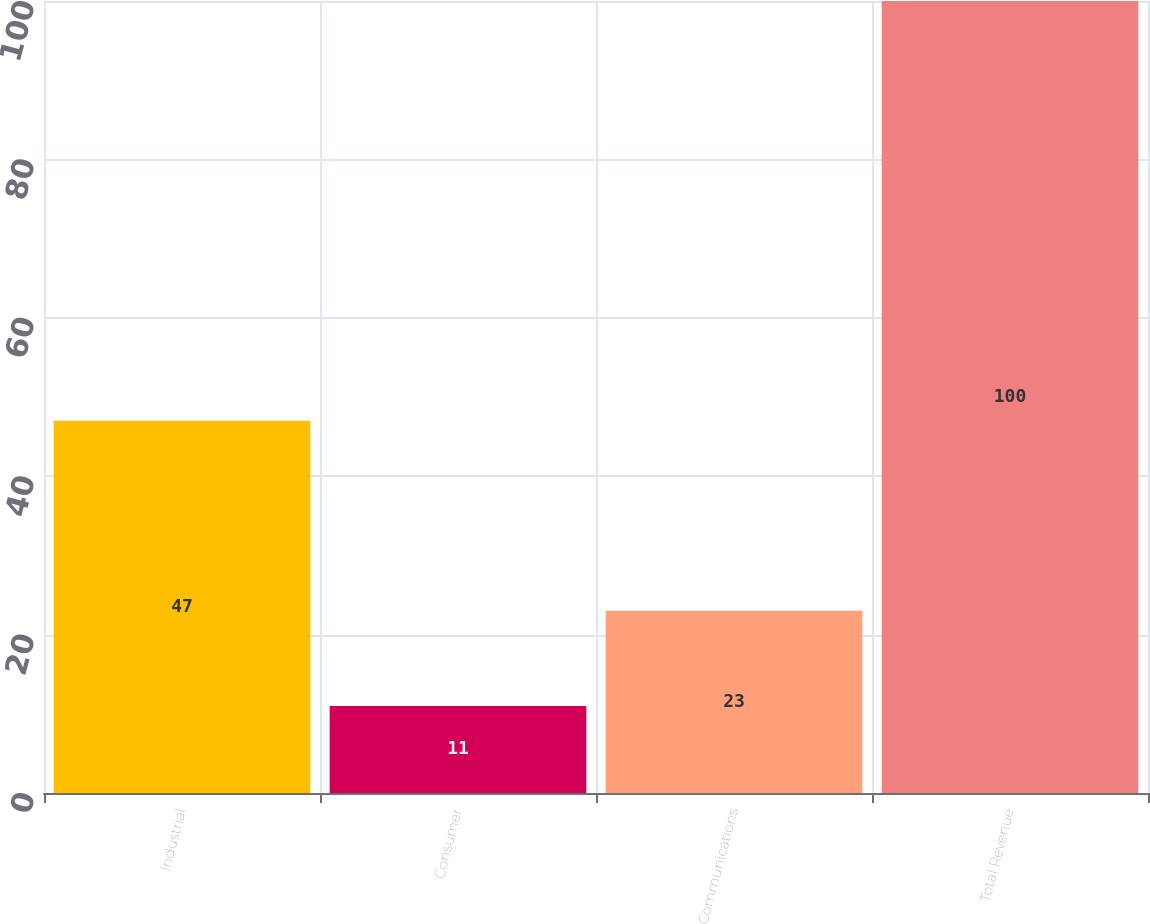Convert chart. <chart><loc_0><loc_0><loc_500><loc_500><bar_chart><fcel>Industrial<fcel>Consumer<fcel>Communications<fcel>Total Revenue<nl><fcel>47<fcel>11<fcel>23<fcel>100<nl></chart> 